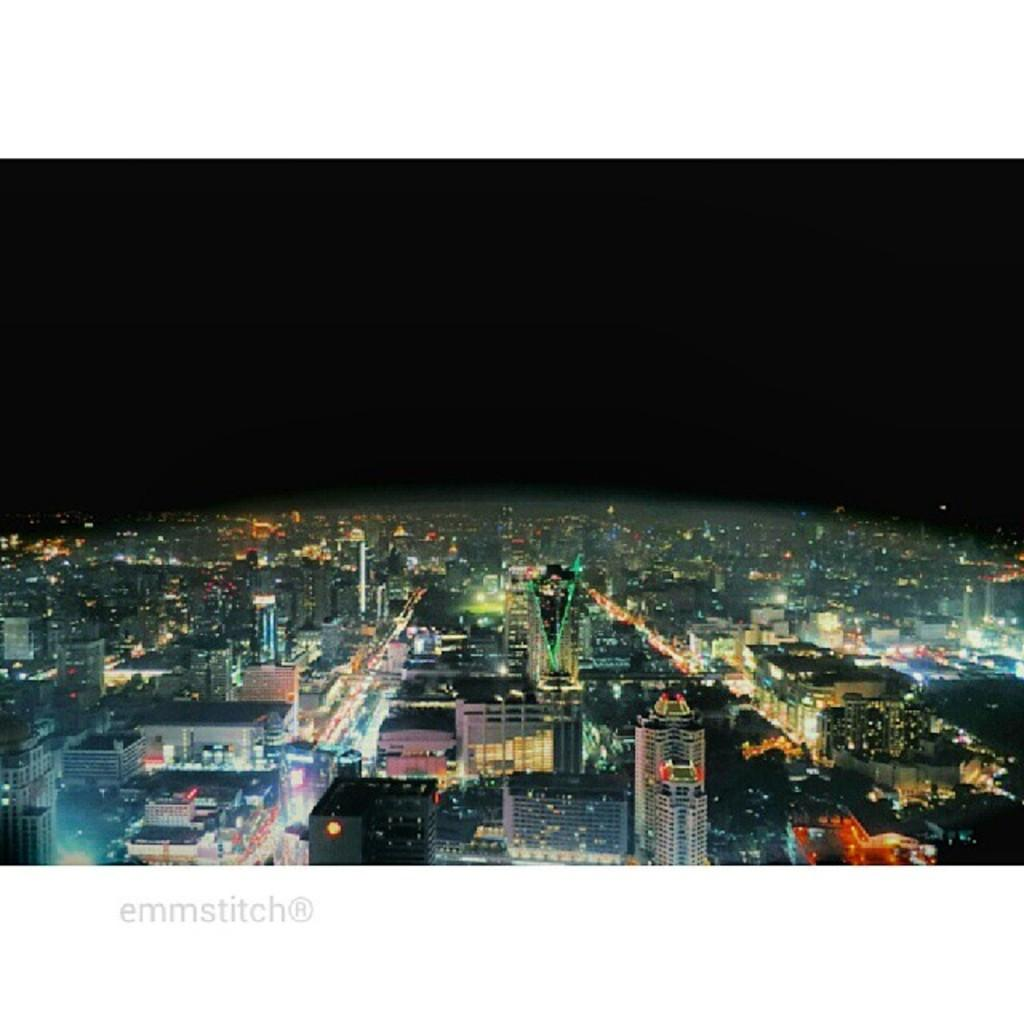What type of structures are illuminated in the image? There is a group of buildings with lights in the image. What else can be seen at the bottom of the image? There is some text visible at the bottom of the image. What can be seen in the background of the image? The sky is visible in the background of the image. Can you hear the thunder in the image? There is no sound or indication of thunder in the image; it is a still image. 